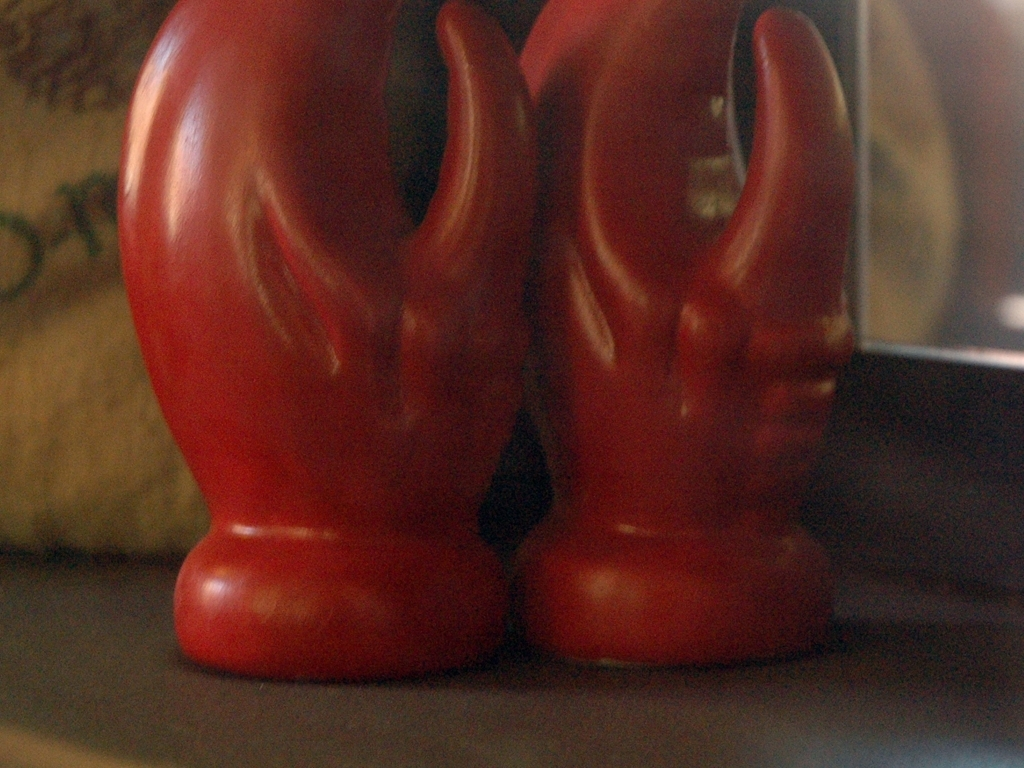Is the image affected by poor image quality? Yes, the image appears blurry and lacks sharpness, which suggests a low resolution or a focus issue when the photo was taken. This affects the ability to see fine details and might detract from the overall visual experience. 